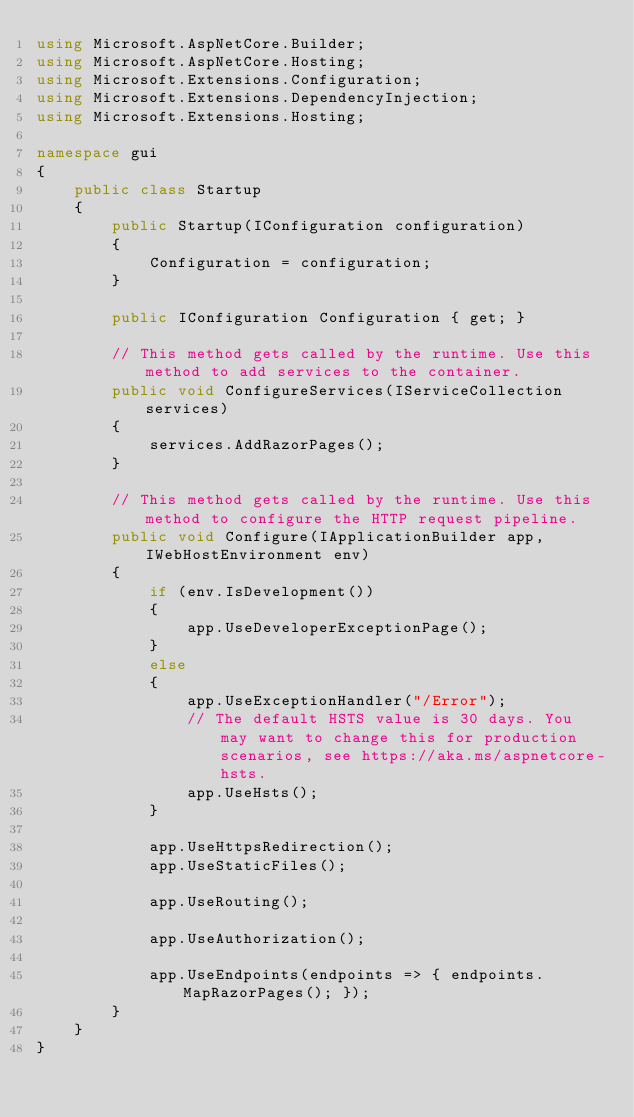Convert code to text. <code><loc_0><loc_0><loc_500><loc_500><_C#_>using Microsoft.AspNetCore.Builder;
using Microsoft.AspNetCore.Hosting;
using Microsoft.Extensions.Configuration;
using Microsoft.Extensions.DependencyInjection;
using Microsoft.Extensions.Hosting;

namespace gui
{
    public class Startup
    {
        public Startup(IConfiguration configuration)
        {
            Configuration = configuration;
        }

        public IConfiguration Configuration { get; }

        // This method gets called by the runtime. Use this method to add services to the container.
        public void ConfigureServices(IServiceCollection services)
        {
            services.AddRazorPages();
        }

        // This method gets called by the runtime. Use this method to configure the HTTP request pipeline.
        public void Configure(IApplicationBuilder app, IWebHostEnvironment env)
        {
            if (env.IsDevelopment())
            {
                app.UseDeveloperExceptionPage();
            }
            else
            {
                app.UseExceptionHandler("/Error");
                // The default HSTS value is 30 days. You may want to change this for production scenarios, see https://aka.ms/aspnetcore-hsts.
                app.UseHsts();
            }

            app.UseHttpsRedirection();
            app.UseStaticFiles();

            app.UseRouting();

            app.UseAuthorization();

            app.UseEndpoints(endpoints => { endpoints.MapRazorPages(); });
        }
    }
}</code> 